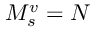Convert formula to latex. <formula><loc_0><loc_0><loc_500><loc_500>M _ { s } ^ { v } = N</formula> 